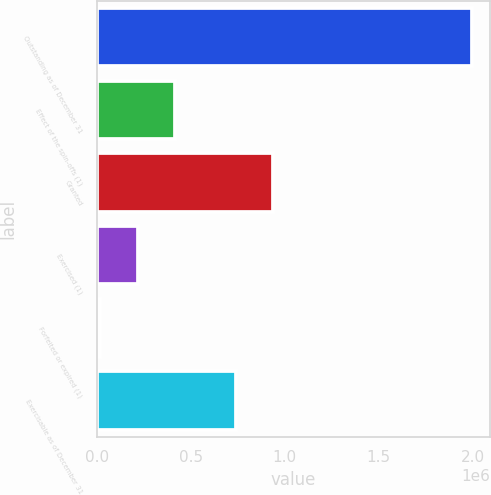Convert chart to OTSL. <chart><loc_0><loc_0><loc_500><loc_500><bar_chart><fcel>Outstanding as of December 31<fcel>Effect of the spin-offs (1)<fcel>Granted<fcel>Exercised (1)<fcel>Forfeited or expired (1)<fcel>Exercisable as of December 31<nl><fcel>1.99345e+06<fcel>415330<fcel>939064<fcel>218064<fcel>20799<fcel>741798<nl></chart> 